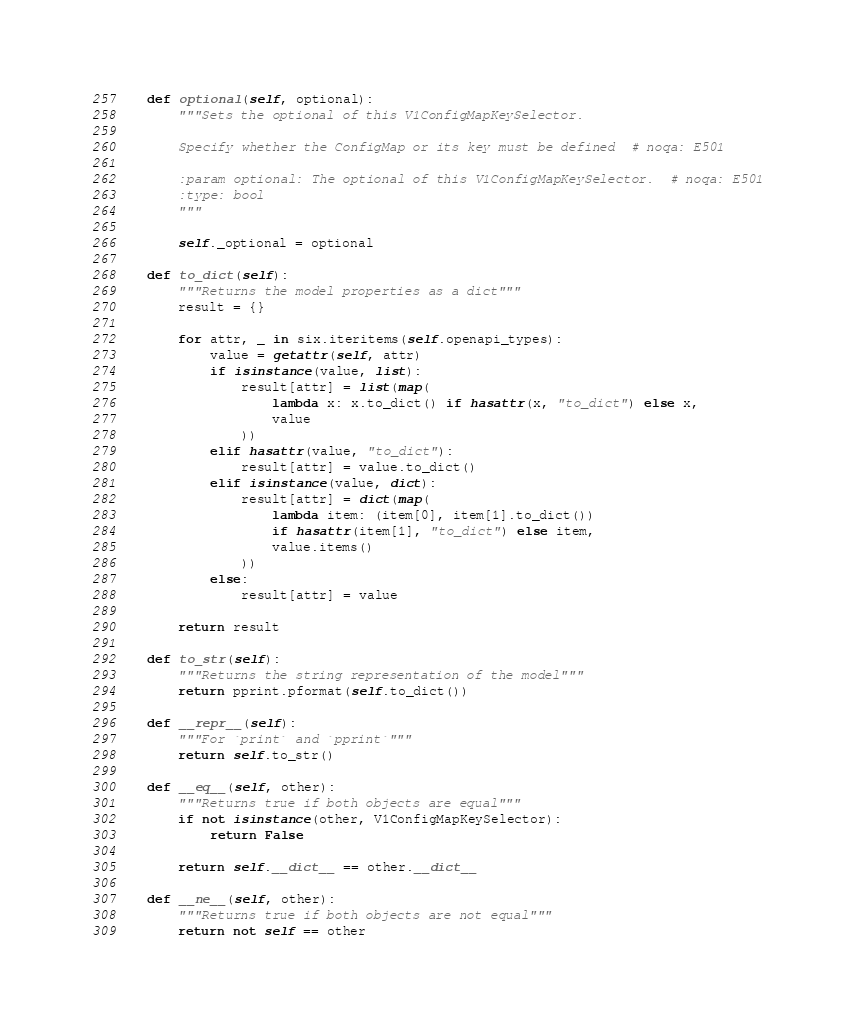<code> <loc_0><loc_0><loc_500><loc_500><_Python_>    def optional(self, optional):
        """Sets the optional of this V1ConfigMapKeySelector.

        Specify whether the ConfigMap or its key must be defined  # noqa: E501

        :param optional: The optional of this V1ConfigMapKeySelector.  # noqa: E501
        :type: bool
        """

        self._optional = optional

    def to_dict(self):
        """Returns the model properties as a dict"""
        result = {}

        for attr, _ in six.iteritems(self.openapi_types):
            value = getattr(self, attr)
            if isinstance(value, list):
                result[attr] = list(map(
                    lambda x: x.to_dict() if hasattr(x, "to_dict") else x,
                    value
                ))
            elif hasattr(value, "to_dict"):
                result[attr] = value.to_dict()
            elif isinstance(value, dict):
                result[attr] = dict(map(
                    lambda item: (item[0], item[1].to_dict())
                    if hasattr(item[1], "to_dict") else item,
                    value.items()
                ))
            else:
                result[attr] = value

        return result

    def to_str(self):
        """Returns the string representation of the model"""
        return pprint.pformat(self.to_dict())

    def __repr__(self):
        """For `print` and `pprint`"""
        return self.to_str()

    def __eq__(self, other):
        """Returns true if both objects are equal"""
        if not isinstance(other, V1ConfigMapKeySelector):
            return False

        return self.__dict__ == other.__dict__

    def __ne__(self, other):
        """Returns true if both objects are not equal"""
        return not self == other
</code> 